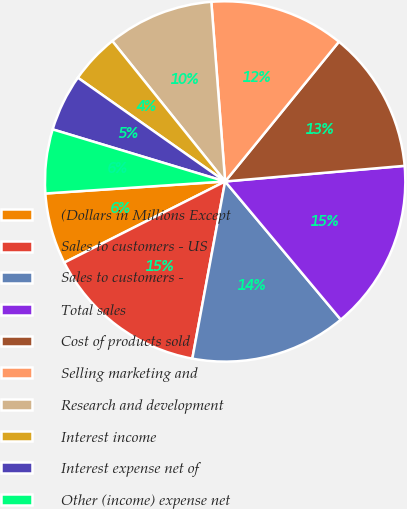Convert chart. <chart><loc_0><loc_0><loc_500><loc_500><pie_chart><fcel>(Dollars in Millions Except<fcel>Sales to customers - US<fcel>Sales to customers -<fcel>Total sales<fcel>Cost of products sold<fcel>Selling marketing and<fcel>Research and development<fcel>Interest income<fcel>Interest expense net of<fcel>Other (income) expense net<nl><fcel>6.37%<fcel>14.65%<fcel>14.01%<fcel>15.29%<fcel>12.74%<fcel>12.1%<fcel>9.55%<fcel>4.46%<fcel>5.1%<fcel>5.73%<nl></chart> 